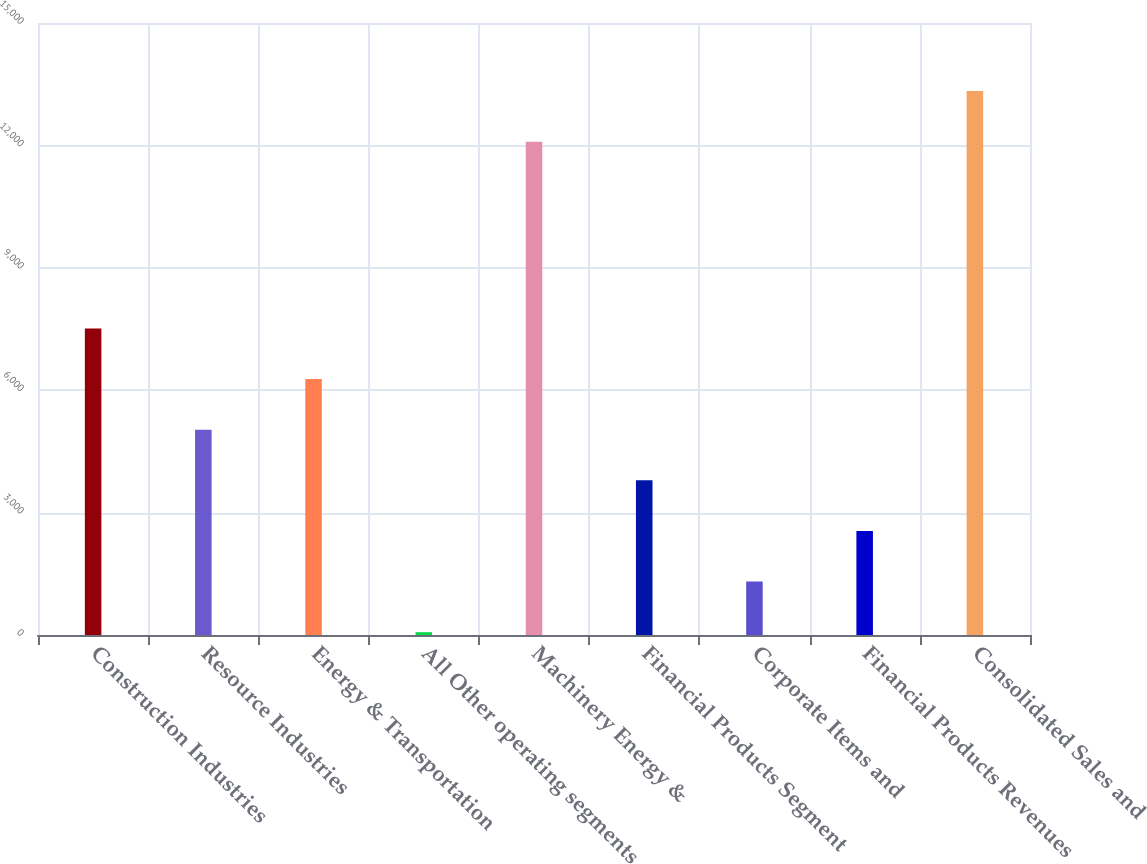Convert chart. <chart><loc_0><loc_0><loc_500><loc_500><bar_chart><fcel>Construction Industries<fcel>Resource Industries<fcel>Energy & Transportation<fcel>All Other operating segments<fcel>Machinery Energy &<fcel>Financial Products Segment<fcel>Corporate Items and<fcel>Financial Products Revenues<fcel>Consolidated Sales and<nl><fcel>7513<fcel>5032<fcel>6272.5<fcel>70<fcel>12090<fcel>3791.5<fcel>1310.5<fcel>2551<fcel>13330.5<nl></chart> 